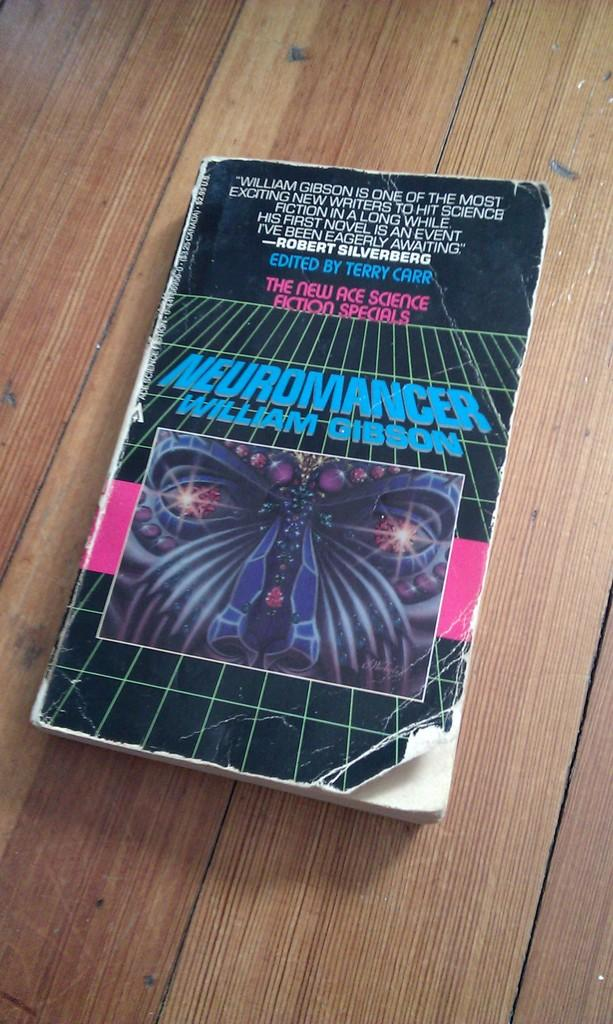<image>
Render a clear and concise summary of the photo. A book by William Gibson is called Neuromancer. 